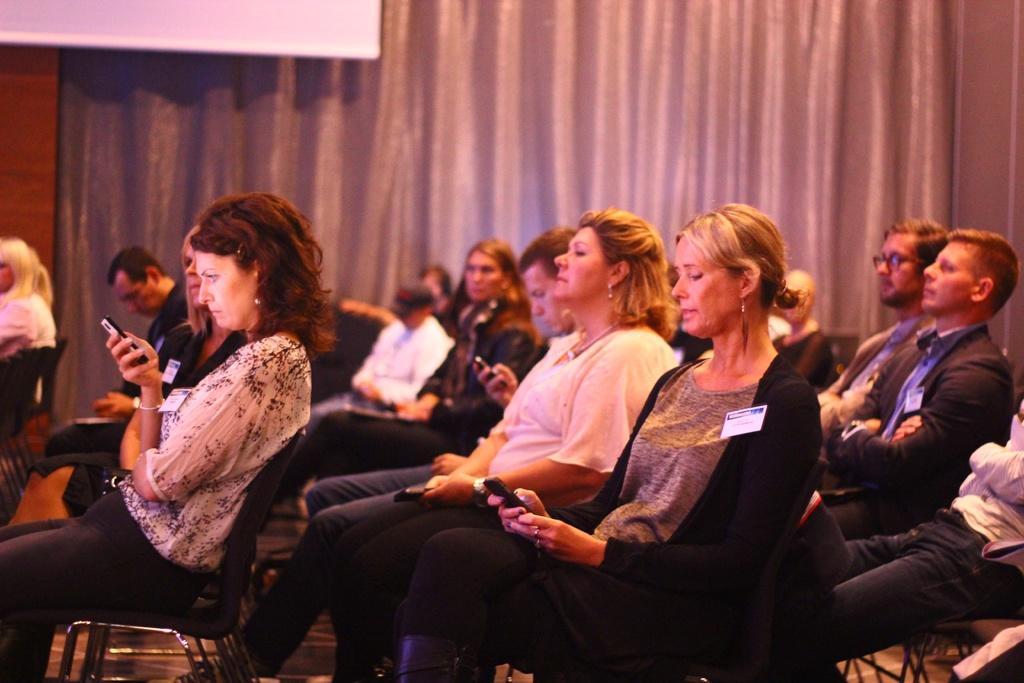Please provide a concise description of this image. In the image we can see there are people sitting on the chair and few people are holding mobile phones in her hand. Behind there is curtain. 